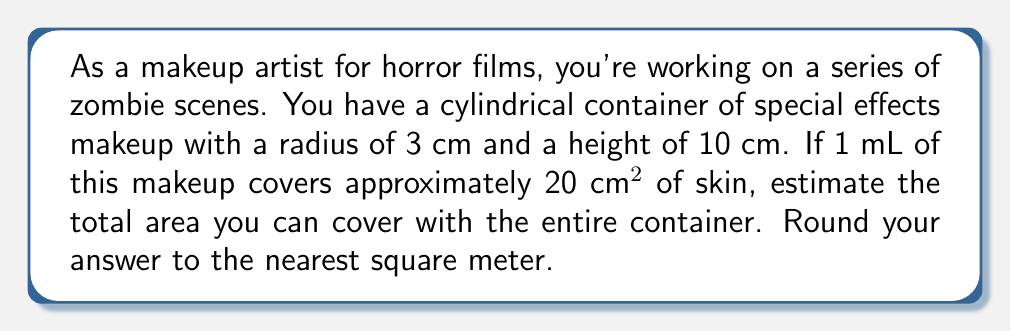Solve this math problem. Let's approach this step-by-step:

1) First, we need to calculate the volume of the makeup container.
   The volume of a cylinder is given by the formula: $V = \pi r^2 h$
   Where $r$ is the radius and $h$ is the height.

2) Substituting the values:
   $V = \pi \cdot (3\text{ cm})^2 \cdot 10\text{ cm}$
   $V = \pi \cdot 9\text{ cm}^2 \cdot 10\text{ cm}$
   $V = 90\pi\text{ cm}^3$

3) We know that 1 cm³ = 1 mL, so the volume in mL is also $90\pi\text{ mL}$.

4) Now, we're told that 1 mL covers 20 cm². So to find the total area covered, we multiply:
   Area = $90\pi\text{ mL} \cdot 20\text{ cm}^2/\text{mL}$
   Area = $1800\pi\text{ cm}^2$

5) Calculate this:
   Area ≈ 5654.87 cm²

6) Convert to square meters:
   $5654.87\text{ cm}^2 \cdot (\frac{1\text{ m}}{100\text{ cm}})^2 = 0.565487\text{ m}^2$

7) Rounding to the nearest square meter:
   0.565487 m² ≈ 1 m²
Answer: 1 m² 